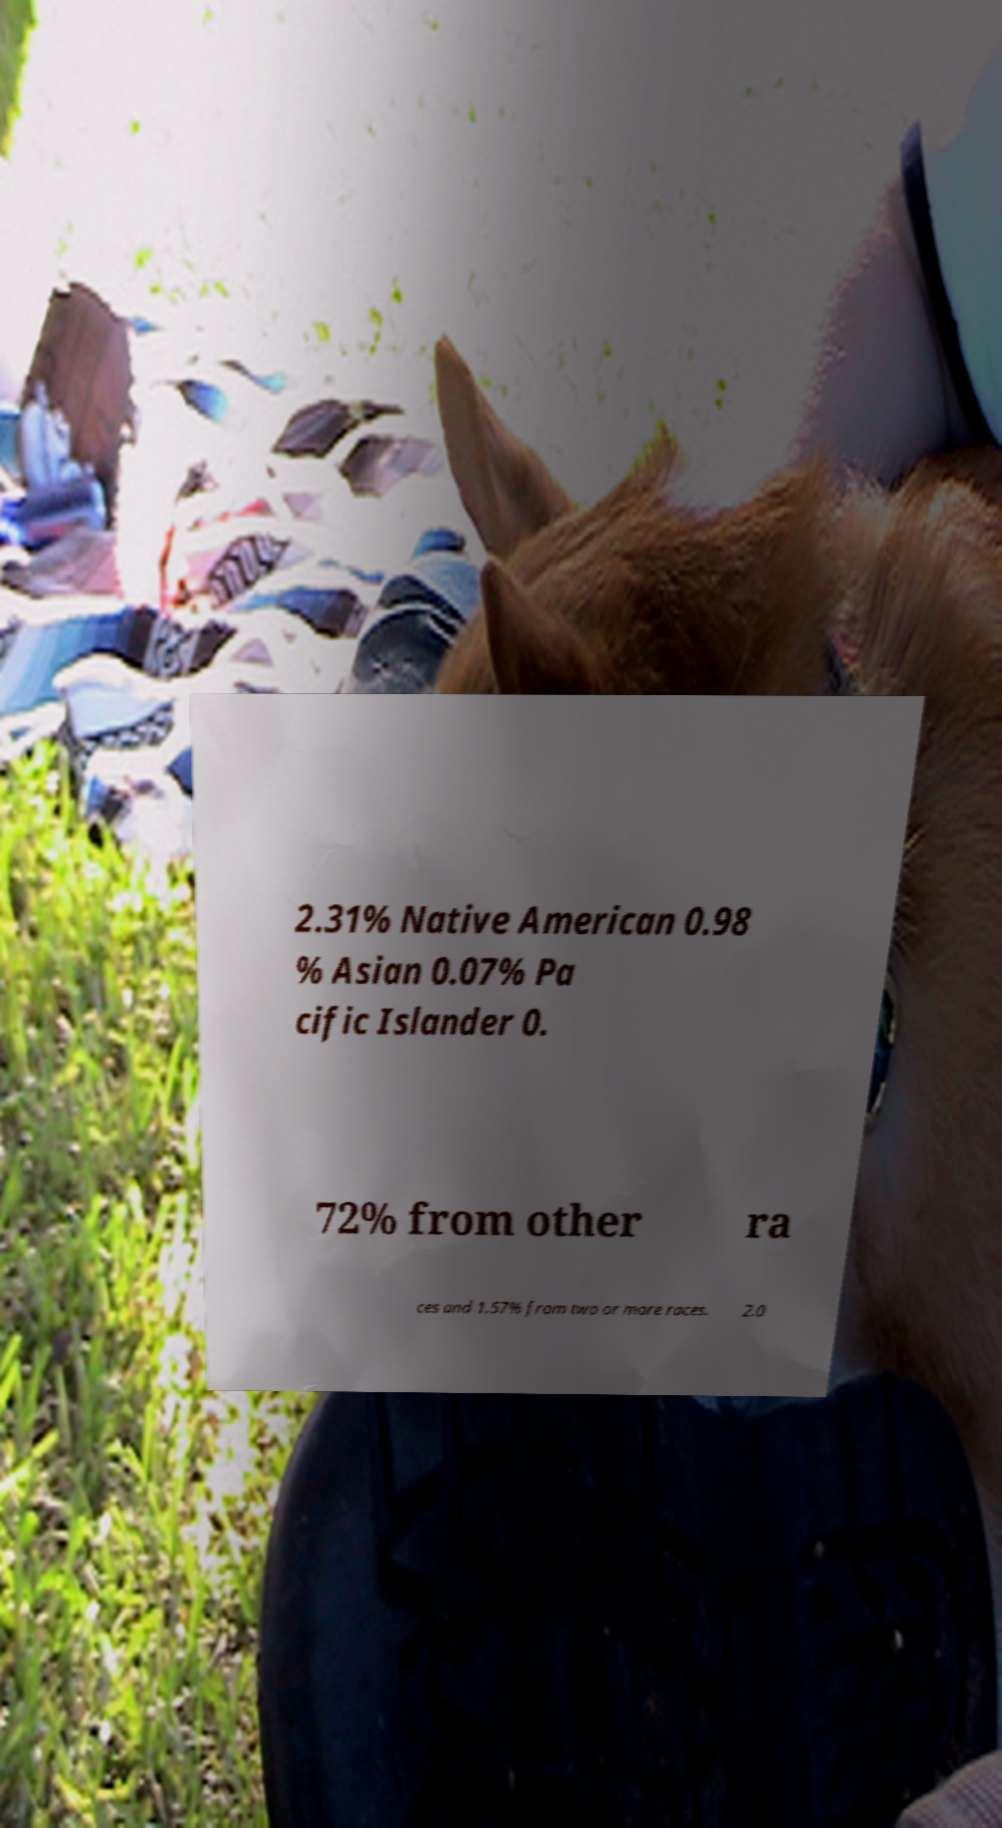There's text embedded in this image that I need extracted. Can you transcribe it verbatim? 2.31% Native American 0.98 % Asian 0.07% Pa cific Islander 0. 72% from other ra ces and 1.57% from two or more races. 2.0 